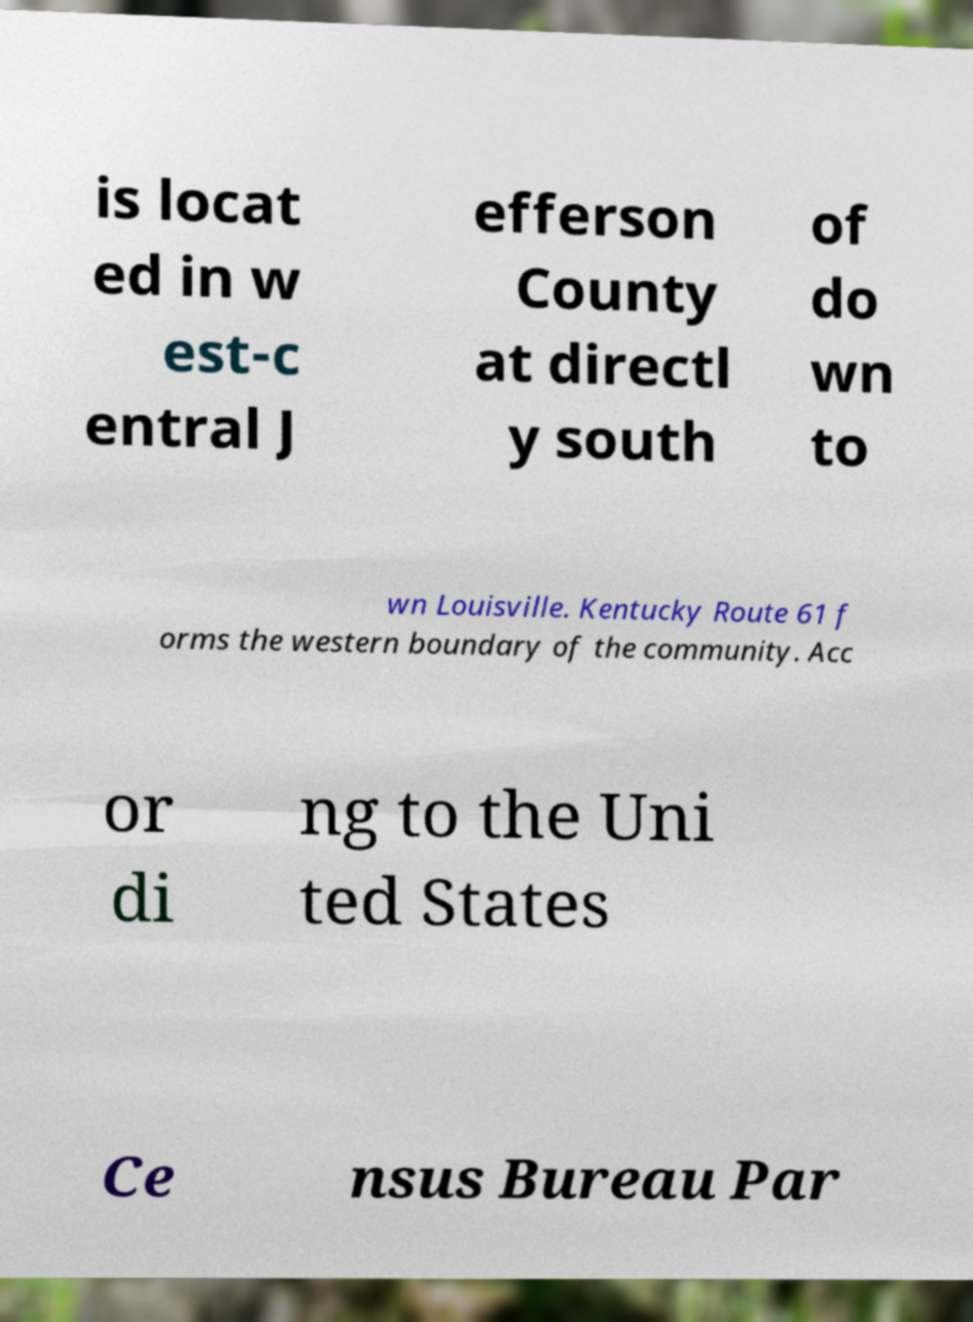I need the written content from this picture converted into text. Can you do that? is locat ed in w est-c entral J efferson County at directl y south of do wn to wn Louisville. Kentucky Route 61 f orms the western boundary of the community. Acc or di ng to the Uni ted States Ce nsus Bureau Par 